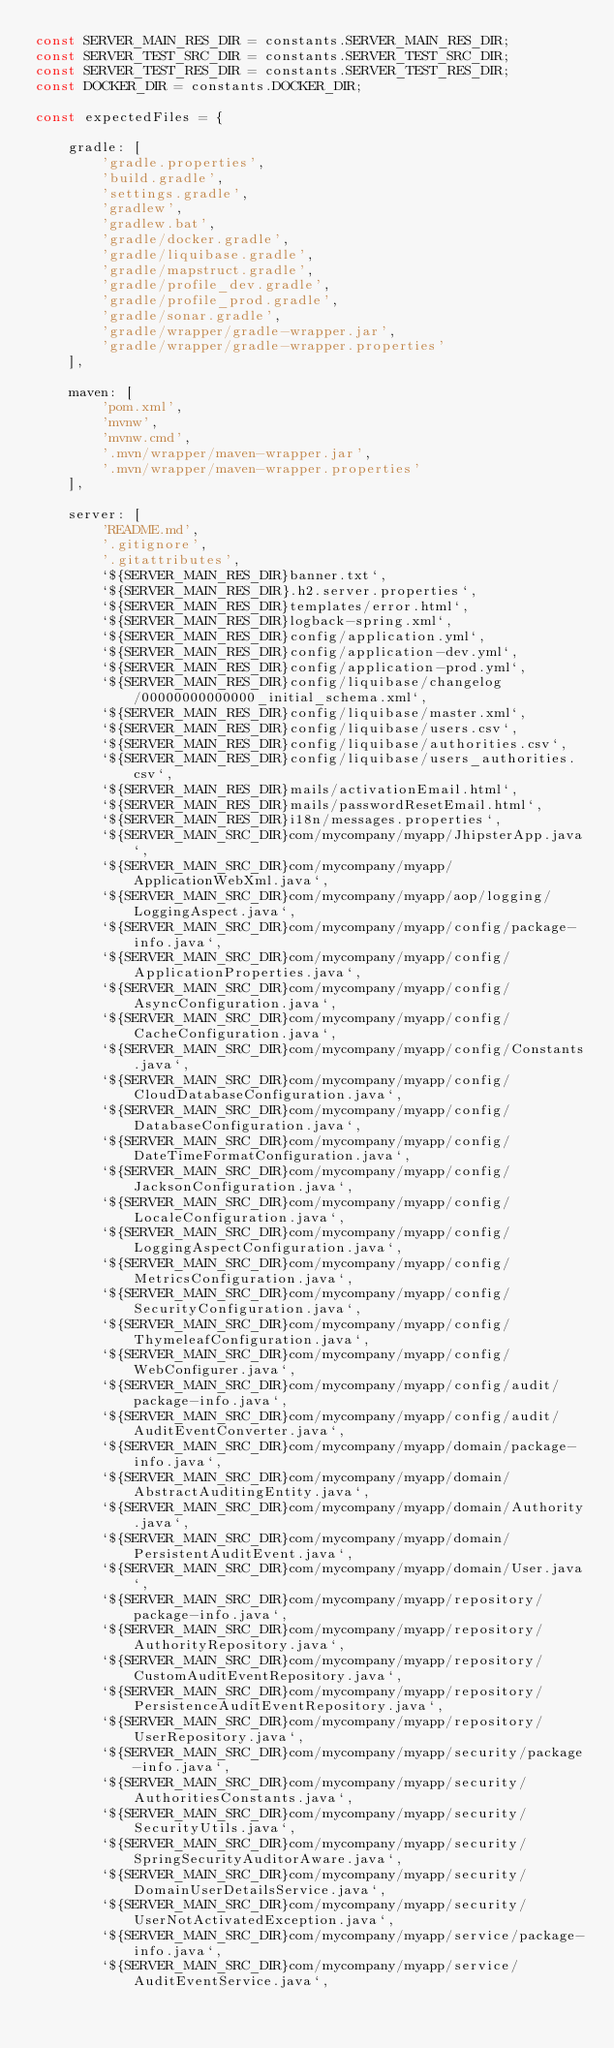<code> <loc_0><loc_0><loc_500><loc_500><_JavaScript_>const SERVER_MAIN_RES_DIR = constants.SERVER_MAIN_RES_DIR;
const SERVER_TEST_SRC_DIR = constants.SERVER_TEST_SRC_DIR;
const SERVER_TEST_RES_DIR = constants.SERVER_TEST_RES_DIR;
const DOCKER_DIR = constants.DOCKER_DIR;

const expectedFiles = {

    gradle: [
        'gradle.properties',
        'build.gradle',
        'settings.gradle',
        'gradlew',
        'gradlew.bat',
        'gradle/docker.gradle',
        'gradle/liquibase.gradle',
        'gradle/mapstruct.gradle',
        'gradle/profile_dev.gradle',
        'gradle/profile_prod.gradle',
        'gradle/sonar.gradle',
        'gradle/wrapper/gradle-wrapper.jar',
        'gradle/wrapper/gradle-wrapper.properties'
    ],

    maven: [
        'pom.xml',
        'mvnw',
        'mvnw.cmd',
        '.mvn/wrapper/maven-wrapper.jar',
        '.mvn/wrapper/maven-wrapper.properties'
    ],

    server: [
        'README.md',
        '.gitignore',
        '.gitattributes',
        `${SERVER_MAIN_RES_DIR}banner.txt`,
        `${SERVER_MAIN_RES_DIR}.h2.server.properties`,
        `${SERVER_MAIN_RES_DIR}templates/error.html`,
        `${SERVER_MAIN_RES_DIR}logback-spring.xml`,
        `${SERVER_MAIN_RES_DIR}config/application.yml`,
        `${SERVER_MAIN_RES_DIR}config/application-dev.yml`,
        `${SERVER_MAIN_RES_DIR}config/application-prod.yml`,
        `${SERVER_MAIN_RES_DIR}config/liquibase/changelog/00000000000000_initial_schema.xml`,
        `${SERVER_MAIN_RES_DIR}config/liquibase/master.xml`,
        `${SERVER_MAIN_RES_DIR}config/liquibase/users.csv`,
        `${SERVER_MAIN_RES_DIR}config/liquibase/authorities.csv`,
        `${SERVER_MAIN_RES_DIR}config/liquibase/users_authorities.csv`,
        `${SERVER_MAIN_RES_DIR}mails/activationEmail.html`,
        `${SERVER_MAIN_RES_DIR}mails/passwordResetEmail.html`,
        `${SERVER_MAIN_RES_DIR}i18n/messages.properties`,
        `${SERVER_MAIN_SRC_DIR}com/mycompany/myapp/JhipsterApp.java`,
        `${SERVER_MAIN_SRC_DIR}com/mycompany/myapp/ApplicationWebXml.java`,
        `${SERVER_MAIN_SRC_DIR}com/mycompany/myapp/aop/logging/LoggingAspect.java`,
        `${SERVER_MAIN_SRC_DIR}com/mycompany/myapp/config/package-info.java`,
        `${SERVER_MAIN_SRC_DIR}com/mycompany/myapp/config/ApplicationProperties.java`,
        `${SERVER_MAIN_SRC_DIR}com/mycompany/myapp/config/AsyncConfiguration.java`,
        `${SERVER_MAIN_SRC_DIR}com/mycompany/myapp/config/CacheConfiguration.java`,
        `${SERVER_MAIN_SRC_DIR}com/mycompany/myapp/config/Constants.java`,
        `${SERVER_MAIN_SRC_DIR}com/mycompany/myapp/config/CloudDatabaseConfiguration.java`,
        `${SERVER_MAIN_SRC_DIR}com/mycompany/myapp/config/DatabaseConfiguration.java`,
        `${SERVER_MAIN_SRC_DIR}com/mycompany/myapp/config/DateTimeFormatConfiguration.java`,
        `${SERVER_MAIN_SRC_DIR}com/mycompany/myapp/config/JacksonConfiguration.java`,
        `${SERVER_MAIN_SRC_DIR}com/mycompany/myapp/config/LocaleConfiguration.java`,
        `${SERVER_MAIN_SRC_DIR}com/mycompany/myapp/config/LoggingAspectConfiguration.java`,
        `${SERVER_MAIN_SRC_DIR}com/mycompany/myapp/config/MetricsConfiguration.java`,
        `${SERVER_MAIN_SRC_DIR}com/mycompany/myapp/config/SecurityConfiguration.java`,
        `${SERVER_MAIN_SRC_DIR}com/mycompany/myapp/config/ThymeleafConfiguration.java`,
        `${SERVER_MAIN_SRC_DIR}com/mycompany/myapp/config/WebConfigurer.java`,
        `${SERVER_MAIN_SRC_DIR}com/mycompany/myapp/config/audit/package-info.java`,
        `${SERVER_MAIN_SRC_DIR}com/mycompany/myapp/config/audit/AuditEventConverter.java`,
        `${SERVER_MAIN_SRC_DIR}com/mycompany/myapp/domain/package-info.java`,
        `${SERVER_MAIN_SRC_DIR}com/mycompany/myapp/domain/AbstractAuditingEntity.java`,
        `${SERVER_MAIN_SRC_DIR}com/mycompany/myapp/domain/Authority.java`,
        `${SERVER_MAIN_SRC_DIR}com/mycompany/myapp/domain/PersistentAuditEvent.java`,
        `${SERVER_MAIN_SRC_DIR}com/mycompany/myapp/domain/User.java`,
        `${SERVER_MAIN_SRC_DIR}com/mycompany/myapp/repository/package-info.java`,
        `${SERVER_MAIN_SRC_DIR}com/mycompany/myapp/repository/AuthorityRepository.java`,
        `${SERVER_MAIN_SRC_DIR}com/mycompany/myapp/repository/CustomAuditEventRepository.java`,
        `${SERVER_MAIN_SRC_DIR}com/mycompany/myapp/repository/PersistenceAuditEventRepository.java`,
        `${SERVER_MAIN_SRC_DIR}com/mycompany/myapp/repository/UserRepository.java`,
        `${SERVER_MAIN_SRC_DIR}com/mycompany/myapp/security/package-info.java`,
        `${SERVER_MAIN_SRC_DIR}com/mycompany/myapp/security/AuthoritiesConstants.java`,
        `${SERVER_MAIN_SRC_DIR}com/mycompany/myapp/security/SecurityUtils.java`,
        `${SERVER_MAIN_SRC_DIR}com/mycompany/myapp/security/SpringSecurityAuditorAware.java`,
        `${SERVER_MAIN_SRC_DIR}com/mycompany/myapp/security/DomainUserDetailsService.java`,
        `${SERVER_MAIN_SRC_DIR}com/mycompany/myapp/security/UserNotActivatedException.java`,
        `${SERVER_MAIN_SRC_DIR}com/mycompany/myapp/service/package-info.java`,
        `${SERVER_MAIN_SRC_DIR}com/mycompany/myapp/service/AuditEventService.java`,</code> 